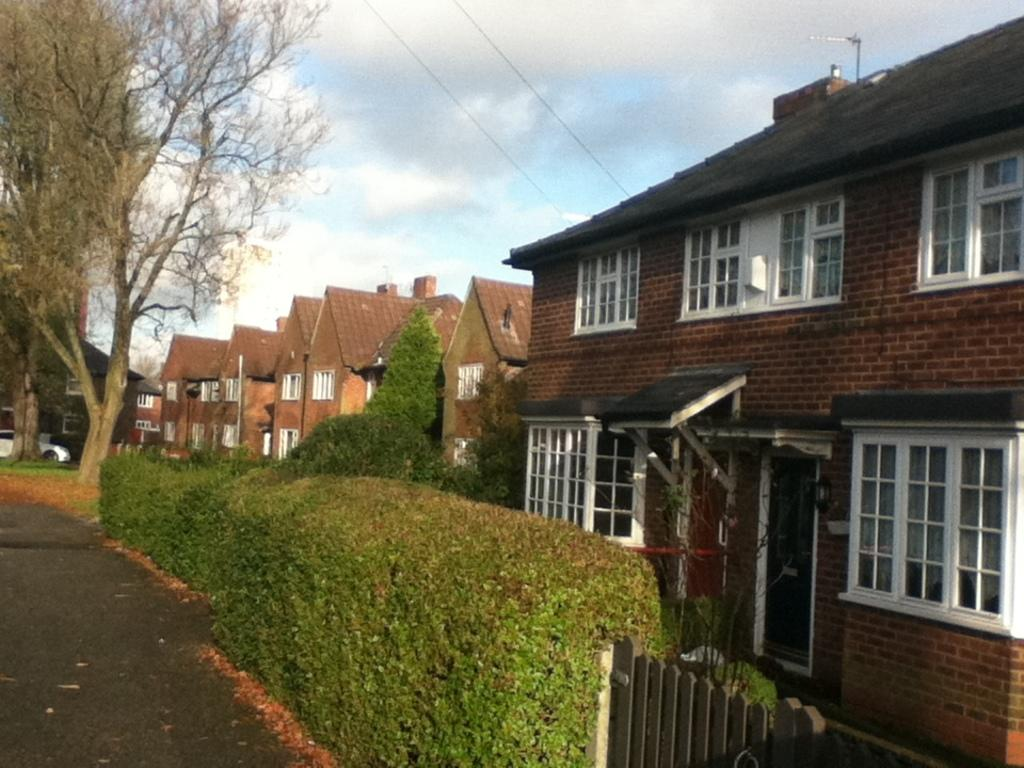Who is present in the image? There is a woman in the image. What object can be seen on the right side of the image? There is a camera on the right side of the image. What object can be seen on the left side of the image? There is a lamp on the left side of the image. What can be seen in the sky in the image? There are clouds in the sky. What type of comfort can be seen in the image? There is no specific type of comfort visible in the image. 